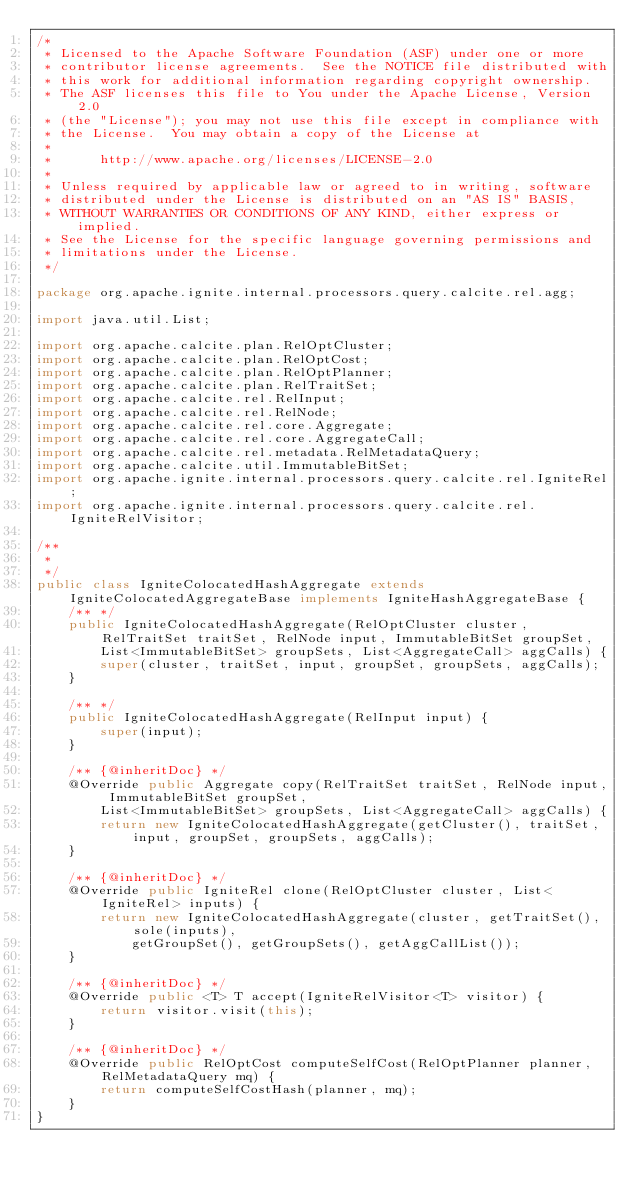Convert code to text. <code><loc_0><loc_0><loc_500><loc_500><_Java_>/*
 * Licensed to the Apache Software Foundation (ASF) under one or more
 * contributor license agreements.  See the NOTICE file distributed with
 * this work for additional information regarding copyright ownership.
 * The ASF licenses this file to You under the Apache License, Version 2.0
 * (the "License"); you may not use this file except in compliance with
 * the License.  You may obtain a copy of the License at
 *
 *      http://www.apache.org/licenses/LICENSE-2.0
 *
 * Unless required by applicable law or agreed to in writing, software
 * distributed under the License is distributed on an "AS IS" BASIS,
 * WITHOUT WARRANTIES OR CONDITIONS OF ANY KIND, either express or implied.
 * See the License for the specific language governing permissions and
 * limitations under the License.
 */

package org.apache.ignite.internal.processors.query.calcite.rel.agg;

import java.util.List;

import org.apache.calcite.plan.RelOptCluster;
import org.apache.calcite.plan.RelOptCost;
import org.apache.calcite.plan.RelOptPlanner;
import org.apache.calcite.plan.RelTraitSet;
import org.apache.calcite.rel.RelInput;
import org.apache.calcite.rel.RelNode;
import org.apache.calcite.rel.core.Aggregate;
import org.apache.calcite.rel.core.AggregateCall;
import org.apache.calcite.rel.metadata.RelMetadataQuery;
import org.apache.calcite.util.ImmutableBitSet;
import org.apache.ignite.internal.processors.query.calcite.rel.IgniteRel;
import org.apache.ignite.internal.processors.query.calcite.rel.IgniteRelVisitor;

/**
 *
 */
public class IgniteColocatedHashAggregate extends IgniteColocatedAggregateBase implements IgniteHashAggregateBase {
    /** */
    public IgniteColocatedHashAggregate(RelOptCluster cluster, RelTraitSet traitSet, RelNode input, ImmutableBitSet groupSet,
        List<ImmutableBitSet> groupSets, List<AggregateCall> aggCalls) {
        super(cluster, traitSet, input, groupSet, groupSets, aggCalls);
    }

    /** */
    public IgniteColocatedHashAggregate(RelInput input) {
        super(input);
    }

    /** {@inheritDoc} */
    @Override public Aggregate copy(RelTraitSet traitSet, RelNode input, ImmutableBitSet groupSet,
        List<ImmutableBitSet> groupSets, List<AggregateCall> aggCalls) {
        return new IgniteColocatedHashAggregate(getCluster(), traitSet, input, groupSet, groupSets, aggCalls);
    }

    /** {@inheritDoc} */
    @Override public IgniteRel clone(RelOptCluster cluster, List<IgniteRel> inputs) {
        return new IgniteColocatedHashAggregate(cluster, getTraitSet(), sole(inputs),
            getGroupSet(), getGroupSets(), getAggCallList());
    }

    /** {@inheritDoc} */
    @Override public <T> T accept(IgniteRelVisitor<T> visitor) {
        return visitor.visit(this);
    }

    /** {@inheritDoc} */
    @Override public RelOptCost computeSelfCost(RelOptPlanner planner, RelMetadataQuery mq) {
        return computeSelfCostHash(planner, mq);
    }
}
</code> 